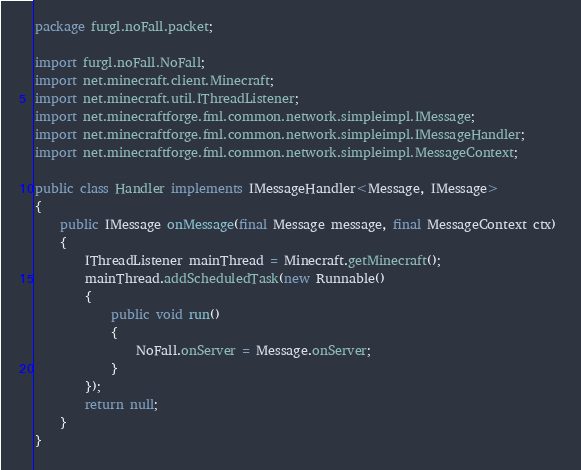<code> <loc_0><loc_0><loc_500><loc_500><_Java_>package furgl.noFall.packet;

import furgl.noFall.NoFall;
import net.minecraft.client.Minecraft;
import net.minecraft.util.IThreadListener;
import net.minecraftforge.fml.common.network.simpleimpl.IMessage;
import net.minecraftforge.fml.common.network.simpleimpl.IMessageHandler;
import net.minecraftforge.fml.common.network.simpleimpl.MessageContext;

public class Handler implements IMessageHandler<Message, IMessage> 
{
	public IMessage onMessage(final Message message, final MessageContext ctx) 
	{
		IThreadListener mainThread = Minecraft.getMinecraft();
		mainThread.addScheduledTask(new Runnable() 
		{
			public void run() 
			{
				NoFall.onServer = Message.onServer;
			}
		});
		return null;
	}
} </code> 